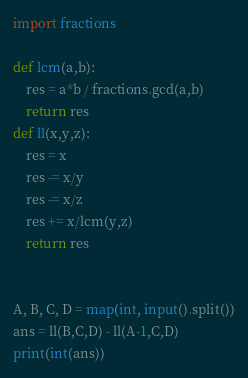<code> <loc_0><loc_0><loc_500><loc_500><_Python_>import fractions

def lcm(a,b):
    res = a*b / fractions.gcd(a,b)
    return res
def ll(x,y,z):
    res = x
    res -= x/y
    res -= x/z
    res += x/lcm(y,z)
    return res


A, B, C, D = map(int, input().split())
ans = ll(B,C,D) - ll(A-1,C,D)
print(int(ans))</code> 